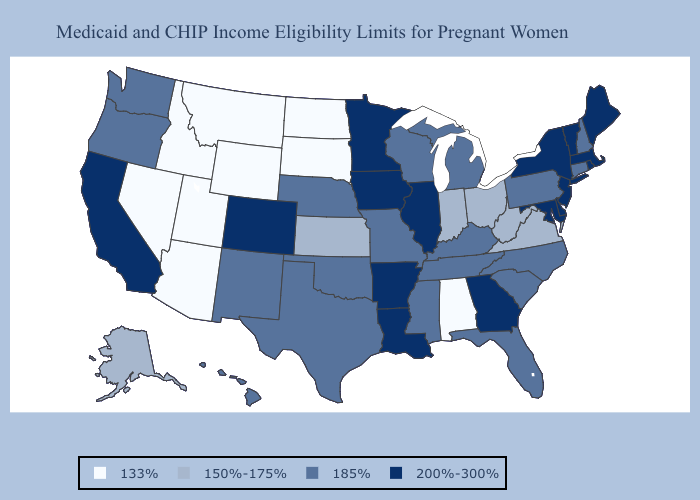What is the value of Texas?
Be succinct. 185%. What is the highest value in states that border New Mexico?
Short answer required. 200%-300%. What is the lowest value in the Northeast?
Quick response, please. 185%. Name the states that have a value in the range 200%-300%?
Quick response, please. Arkansas, California, Colorado, Delaware, Georgia, Illinois, Iowa, Louisiana, Maine, Maryland, Massachusetts, Minnesota, New Jersey, New York, Rhode Island, Vermont. Does Connecticut have a higher value than Washington?
Concise answer only. No. Is the legend a continuous bar?
Answer briefly. No. What is the value of Tennessee?
Short answer required. 185%. What is the value of New York?
Concise answer only. 200%-300%. Among the states that border Georgia , does Tennessee have the highest value?
Answer briefly. Yes. Does the map have missing data?
Write a very short answer. No. What is the value of Louisiana?
Write a very short answer. 200%-300%. Name the states that have a value in the range 185%?
Give a very brief answer. Connecticut, Florida, Hawaii, Kentucky, Michigan, Mississippi, Missouri, Nebraska, New Hampshire, New Mexico, North Carolina, Oklahoma, Oregon, Pennsylvania, South Carolina, Tennessee, Texas, Washington, Wisconsin. Among the states that border Nevada , which have the lowest value?
Keep it brief. Arizona, Idaho, Utah. What is the value of Montana?
Answer briefly. 133%. Which states have the lowest value in the USA?
Short answer required. Alabama, Arizona, Idaho, Montana, Nevada, North Dakota, South Dakota, Utah, Wyoming. 